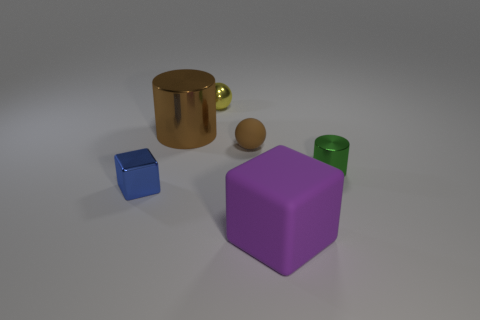What can you tell me about the lighting in this scene? The lighting in the scene seems diffused, creating soft shadows under the objects. There are no harsh highlights or deep shadows, indicating that the light source, or sources, are probably large and not directly aimed at the objects, contributing to the soft and calm atmosphere of the scene. 